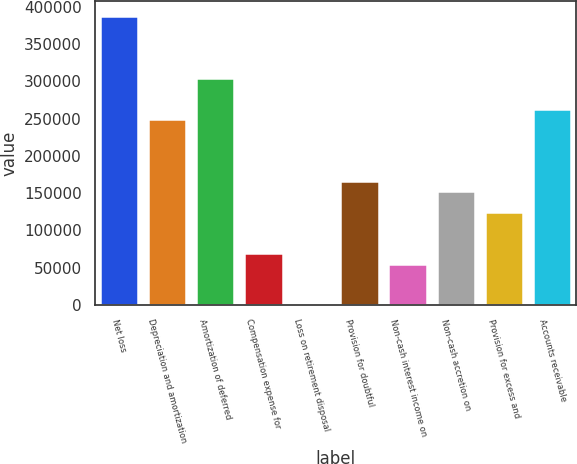<chart> <loc_0><loc_0><loc_500><loc_500><bar_chart><fcel>Net loss<fcel>Depreciation and amortization<fcel>Amortization of deferred<fcel>Compensation expense for<fcel>Loss on retirement disposal<fcel>Provision for doubtful<fcel>Non-cash interest income on<fcel>Non-cash accretion on<fcel>Provision for excess and<fcel>Accounts receivable<nl><fcel>388034<fcel>249463<fcel>304891<fcel>69320.5<fcel>35<fcel>166320<fcel>55463.4<fcel>152463<fcel>124749<fcel>263320<nl></chart> 